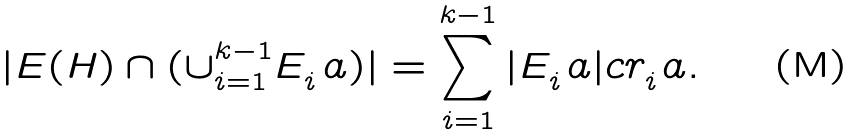Convert formula to latex. <formula><loc_0><loc_0><loc_500><loc_500>| E ( H ) \cap ( \cup _ { i = 1 } ^ { k - 1 } E _ { i } ^ { \ } a ) | = \sum _ { i = 1 } ^ { k - 1 } | E _ { i } ^ { \ } a | c r _ { i } ^ { \ } a .</formula> 